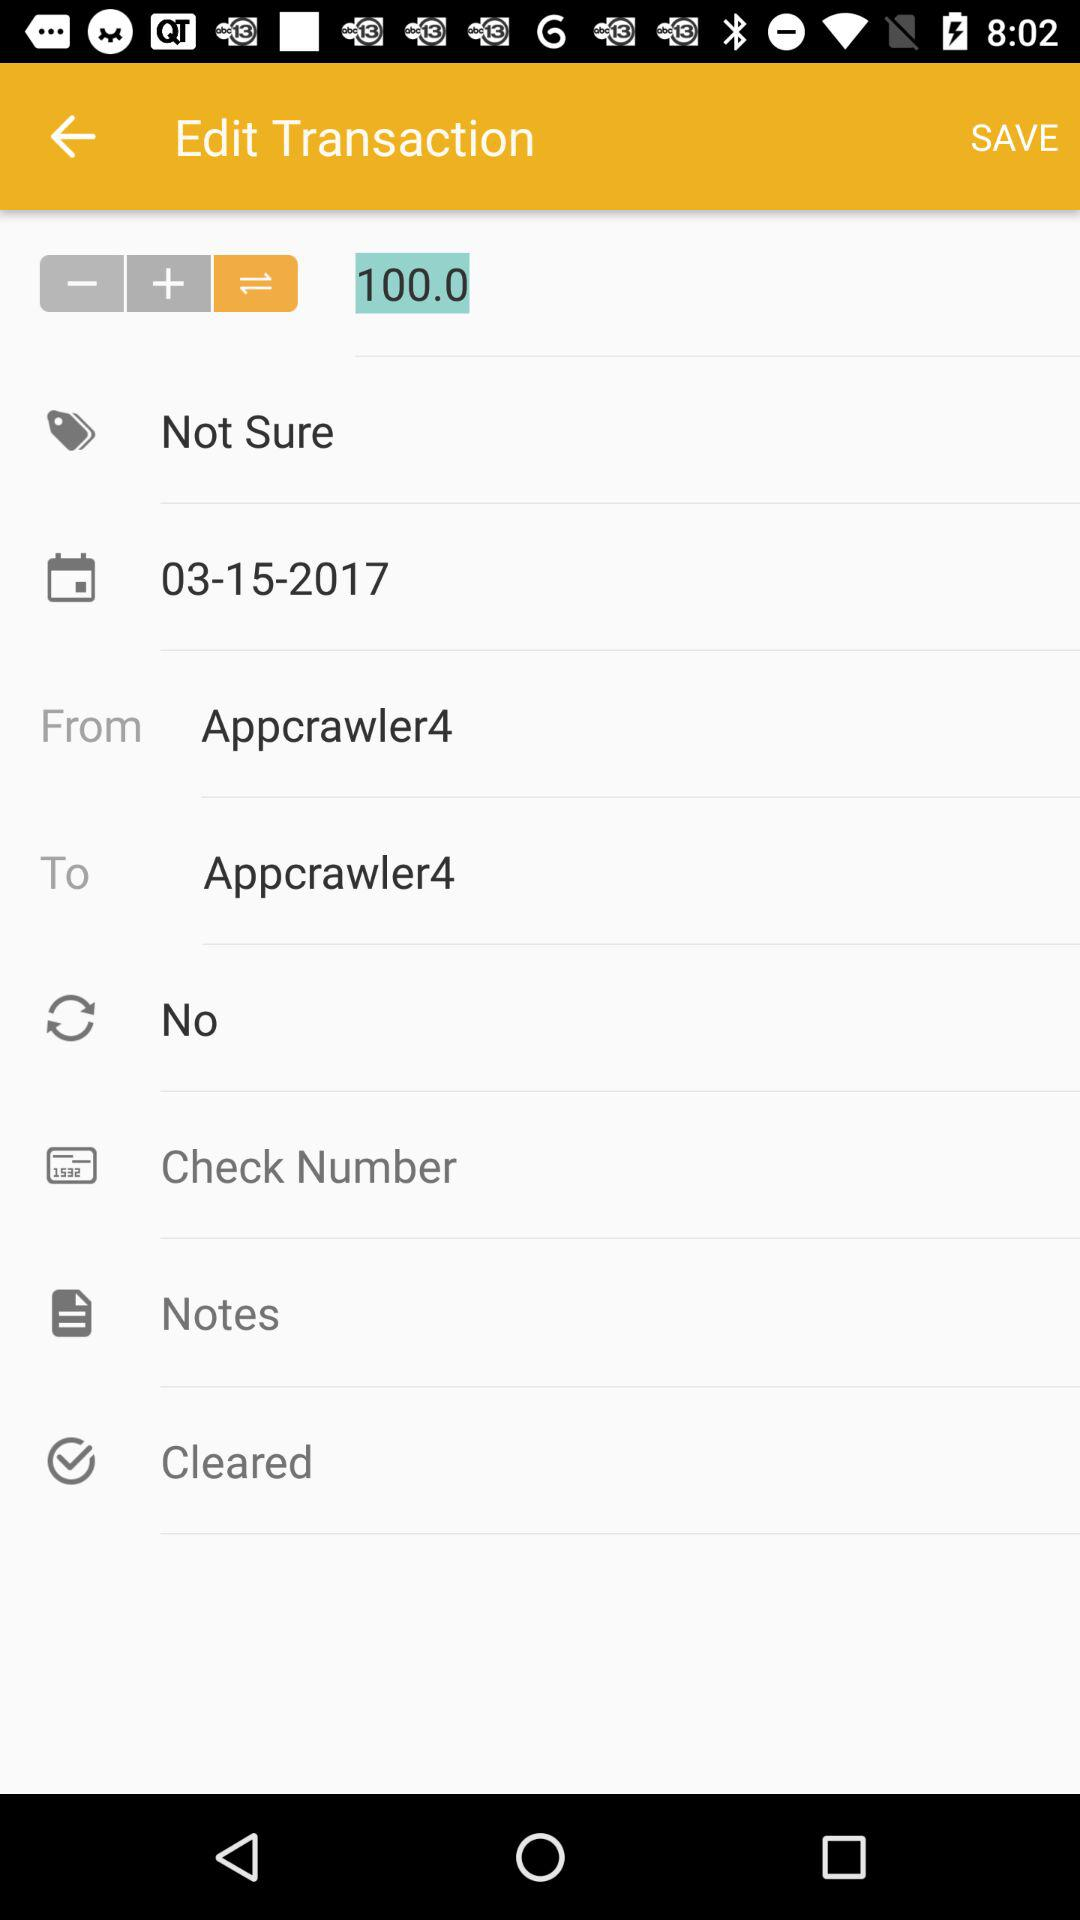Who is the sender? The sender is Appcrawler4. 